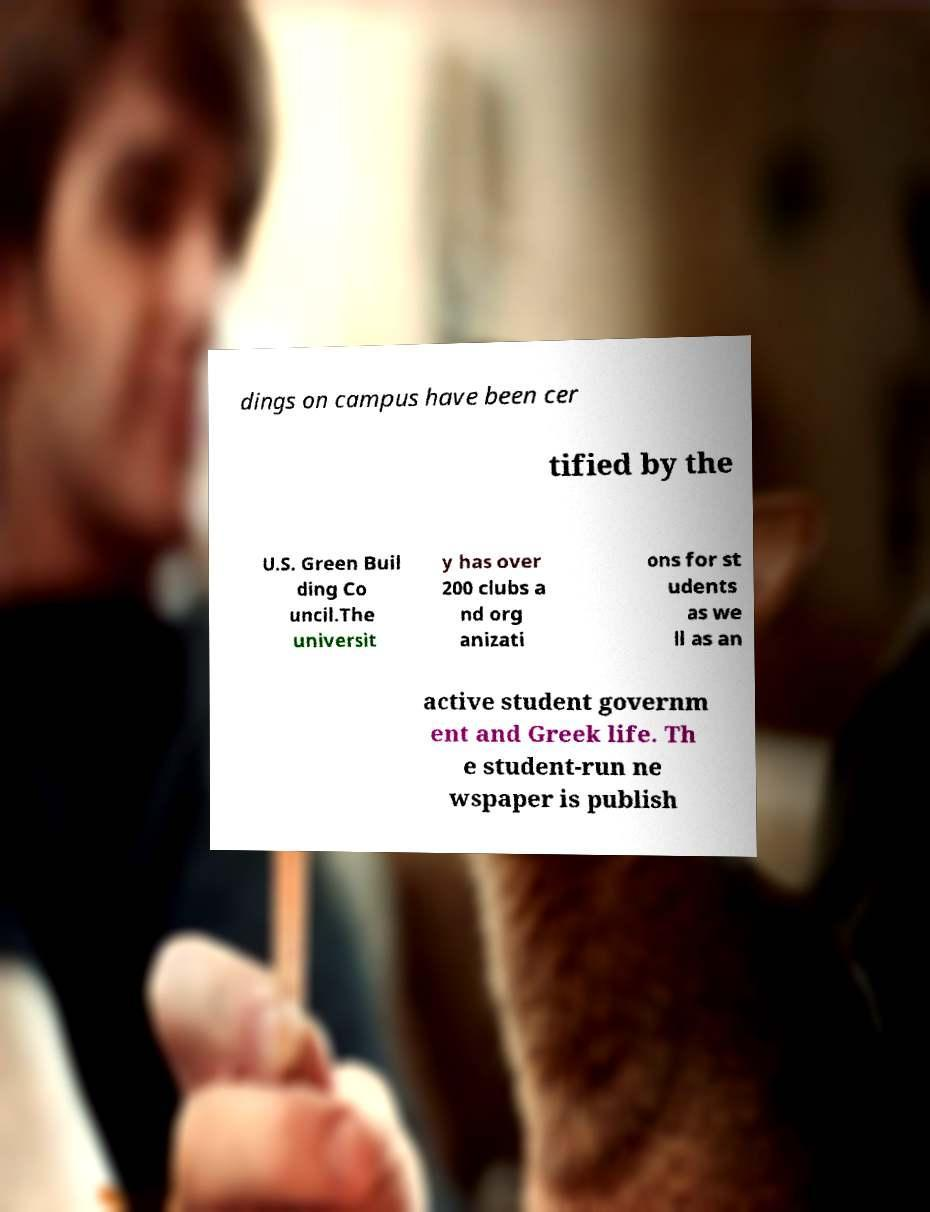Could you assist in decoding the text presented in this image and type it out clearly? dings on campus have been cer tified by the U.S. Green Buil ding Co uncil.The universit y has over 200 clubs a nd org anizati ons for st udents as we ll as an active student governm ent and Greek life. Th e student-run ne wspaper is publish 